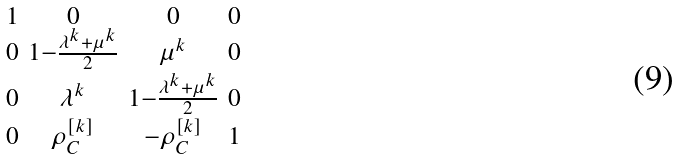<formula> <loc_0><loc_0><loc_500><loc_500>\begin{smallmatrix} 1 & 0 & 0 & 0 \\ 0 & 1 - \frac { \lambda ^ { k } + \mu ^ { k } } { 2 } & \mu ^ { k } & 0 \\ 0 & \lambda ^ { k } & 1 - \frac { \lambda ^ { k } + \mu ^ { k } } { 2 } & 0 \\ 0 & \rho _ { C } ^ { [ k ] } & - \rho _ { C } ^ { [ k ] } & 1 \end{smallmatrix}</formula> 